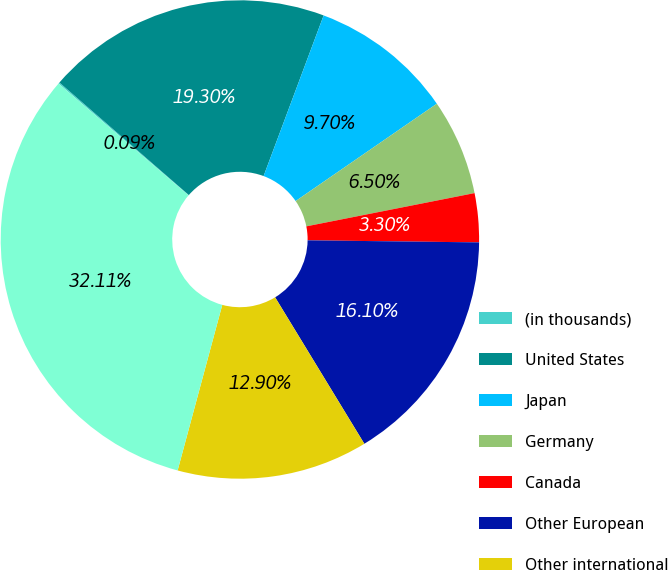Convert chart to OTSL. <chart><loc_0><loc_0><loc_500><loc_500><pie_chart><fcel>(in thousands)<fcel>United States<fcel>Japan<fcel>Germany<fcel>Canada<fcel>Other European<fcel>Other international<fcel>Total revenue<nl><fcel>0.09%<fcel>19.3%<fcel>9.7%<fcel>6.5%<fcel>3.3%<fcel>16.1%<fcel>12.9%<fcel>32.11%<nl></chart> 